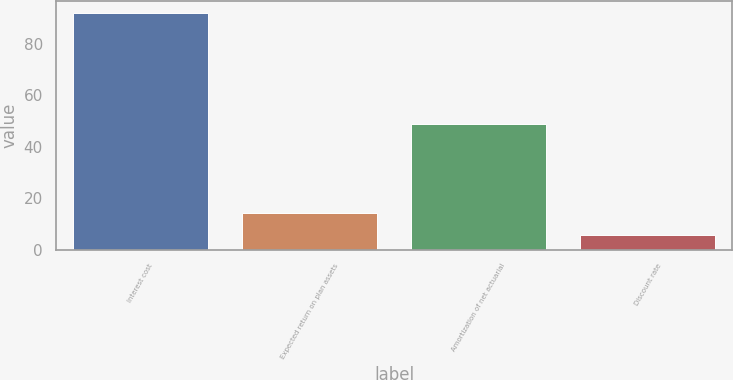<chart> <loc_0><loc_0><loc_500><loc_500><bar_chart><fcel>Interest cost<fcel>Expected return on plan assets<fcel>Amortization of net actuarial<fcel>Discount rate<nl><fcel>92<fcel>14.38<fcel>49<fcel>5.75<nl></chart> 